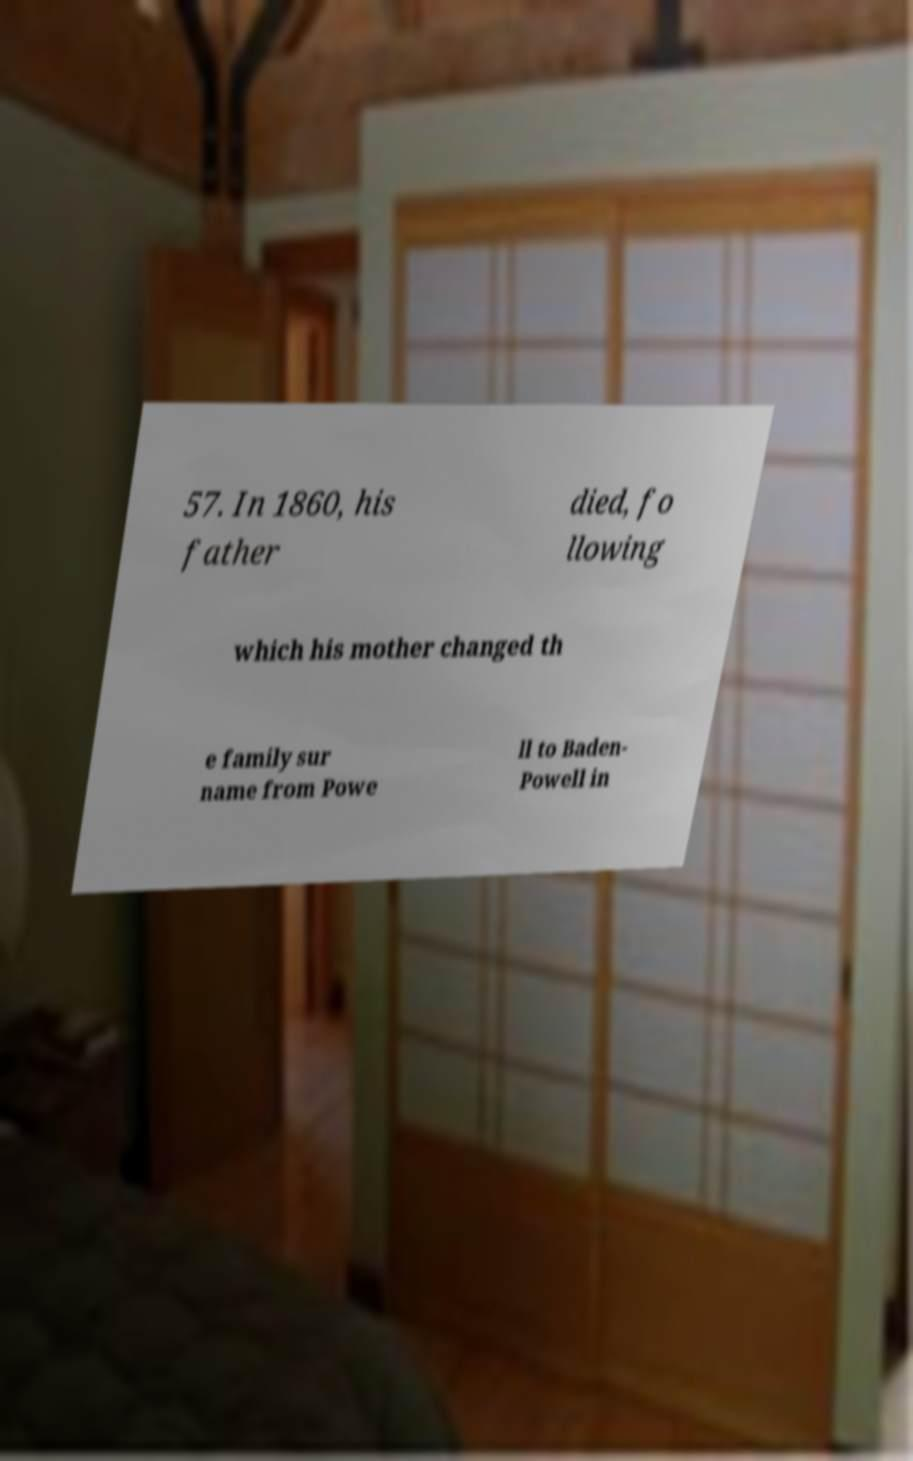For documentation purposes, I need the text within this image transcribed. Could you provide that? 57. In 1860, his father died, fo llowing which his mother changed th e family sur name from Powe ll to Baden- Powell in 